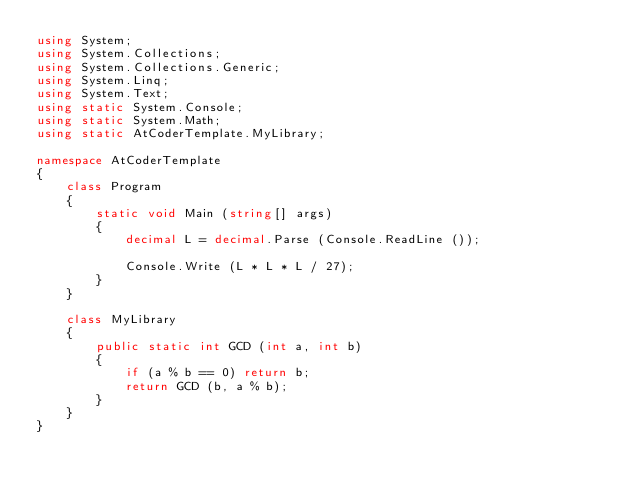Convert code to text. <code><loc_0><loc_0><loc_500><loc_500><_C#_>using System;
using System.Collections;
using System.Collections.Generic;
using System.Linq;
using System.Text;
using static System.Console;
using static System.Math;
using static AtCoderTemplate.MyLibrary;

namespace AtCoderTemplate
{
    class Program
    {
        static void Main (string[] args)
        {
            decimal L = decimal.Parse (Console.ReadLine ());

            Console.Write (L * L * L / 27);
        }
    }

    class MyLibrary
    {
        public static int GCD (int a, int b)
        {
            if (a % b == 0) return b;
            return GCD (b, a % b);
        }
    }
}</code> 